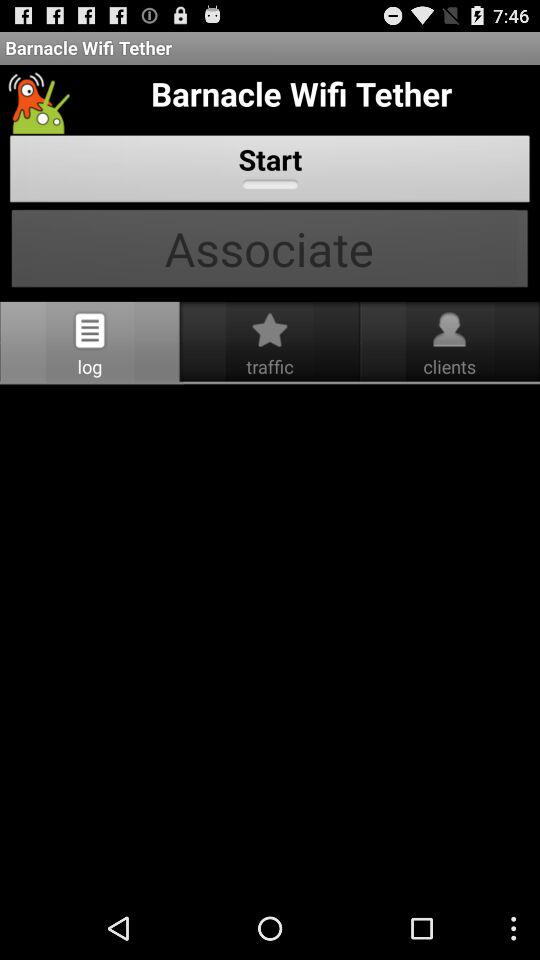Which tab am I on? You are on "log" tab. 